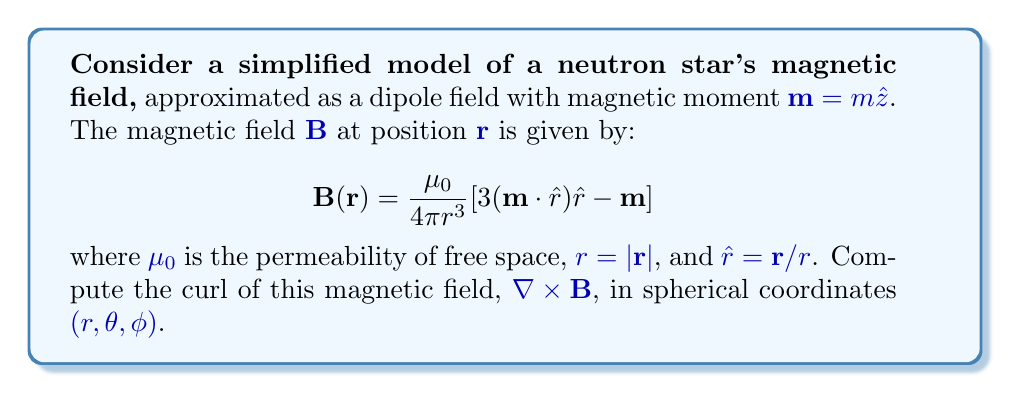Can you solve this math problem? To compute the curl of the magnetic field, we'll follow these steps:

1) First, let's express the magnetic field in spherical coordinates:
   $$\mathbf{B} = \frac{\mu_0 m}{4\pi r^3}(2\cos\theta\hat{r} + \sin\theta\hat{\theta})$$

2) The curl in spherical coordinates is given by:
   $$\nabla \times \mathbf{B} = \frac{1}{r\sin\theta}\left(\frac{\partial}{\partial\theta}(B_\phi\sin\theta) - \frac{\partial B_\theta}{\partial\phi}\right)\hat{r} + \frac{1}{r}\left(\frac{1}{\sin\theta}\frac{\partial B_r}{\partial\phi} - \frac{\partial}{\partial r}(rB_\phi)\right)\hat{\theta} + \frac{1}{r}\left(\frac{\partial}{\partial r}(rB_\theta) - \frac{\partial B_r}{\partial\theta}\right)\hat{\phi}$$

3) We observe that $B_\phi = 0$, and $B_r$ and $B_\theta$ are independent of $\phi$. This simplifies our calculation:
   $$\nabla \times \mathbf{B} = \frac{1}{r}\left(\frac{\partial}{\partial r}(rB_\theta) - \frac{\partial B_r}{\partial\theta}\right)\hat{\phi}$$

4) Let's calculate the derivatives:
   $$\frac{\partial}{\partial r}(rB_\theta) = \frac{\partial}{\partial r}\left(r \cdot \frac{\mu_0 m}{4\pi r^3}\sin\theta\right) = \frac{\mu_0 m}{4\pi r^3}\sin\theta - 3\frac{\mu_0 m}{4\pi r^4}\sin\theta = -\frac{2\mu_0 m}{4\pi r^4}\sin\theta$$
   
   $$\frac{\partial B_r}{\partial\theta} = \frac{\partial}{\partial\theta}\left(\frac{\mu_0 m}{2\pi r^3}\cos\theta\right) = -\frac{\mu_0 m}{2\pi r^3}\sin\theta$$

5) Substituting these back into the curl equation:
   $$\nabla \times \mathbf{B} = \frac{1}{r}\left(-\frac{2\mu_0 m}{4\pi r^4}\sin\theta + \frac{\mu_0 m}{2\pi r^3}\sin\theta\right)\hat{\phi} = 0$$

Therefore, the curl of the magnetic field is zero everywhere outside the neutron star.
Answer: $\nabla \times \mathbf{B} = 0$ 